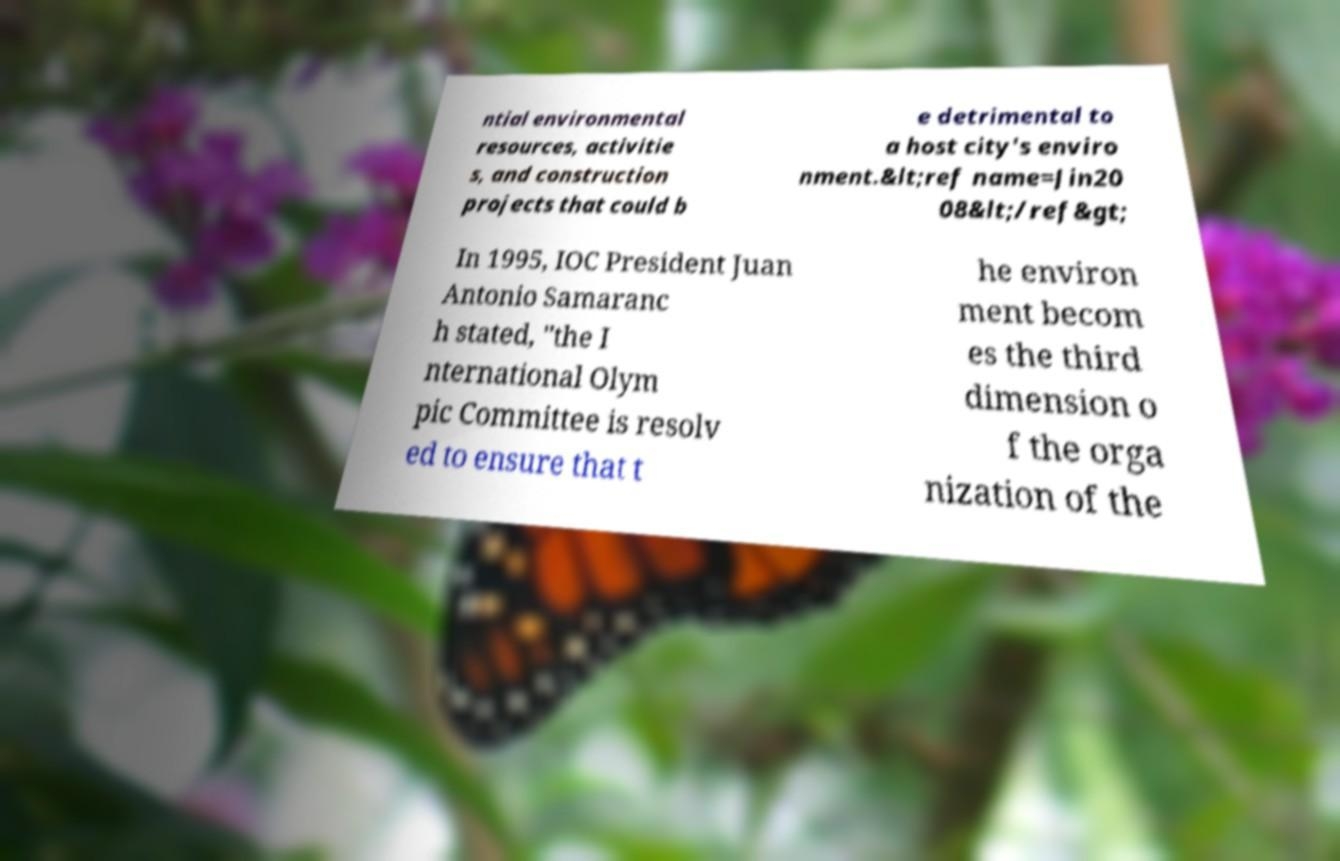Can you accurately transcribe the text from the provided image for me? ntial environmental resources, activitie s, and construction projects that could b e detrimental to a host city's enviro nment.&lt;ref name=Jin20 08&lt;/ref&gt; In 1995, IOC President Juan Antonio Samaranc h stated, "the I nternational Olym pic Committee is resolv ed to ensure that t he environ ment becom es the third dimension o f the orga nization of the 